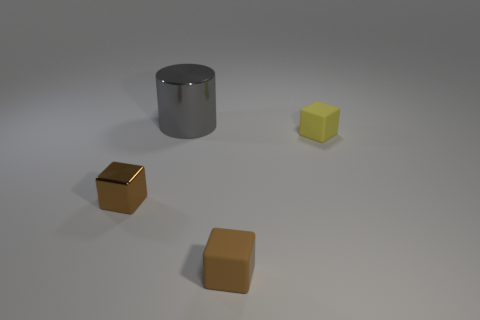There is a metallic object that is in front of the gray cylinder; does it have the same shape as the brown thing right of the cylinder?
Your response must be concise. Yes. There is a brown thing that is the same size as the brown metallic block; what shape is it?
Offer a terse response. Cube. There is a thing that is made of the same material as the cylinder; what is its color?
Provide a succinct answer. Brown. There is a gray shiny thing; is its shape the same as the brown thing that is on the left side of the big gray metal cylinder?
Your response must be concise. No. There is another thing that is the same color as the small metal thing; what material is it?
Your answer should be compact. Rubber. There is a yellow block that is the same size as the brown matte cube; what is its material?
Provide a succinct answer. Rubber. Are there any cubes that have the same color as the tiny metal thing?
Provide a short and direct response. Yes. The object that is right of the big gray shiny thing and in front of the small yellow rubber block has what shape?
Your response must be concise. Cube. What number of other gray cylinders are made of the same material as the large cylinder?
Keep it short and to the point. 0. Are there fewer cubes that are behind the gray metal cylinder than brown blocks that are in front of the brown metal thing?
Give a very brief answer. Yes. 